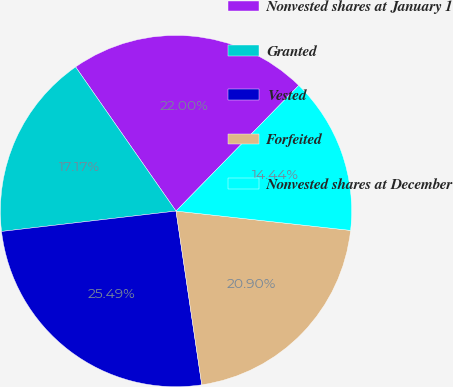<chart> <loc_0><loc_0><loc_500><loc_500><pie_chart><fcel>Nonvested shares at January 1<fcel>Granted<fcel>Vested<fcel>Forfeited<fcel>Nonvested shares at December<nl><fcel>22.0%<fcel>17.17%<fcel>25.49%<fcel>20.9%<fcel>14.44%<nl></chart> 